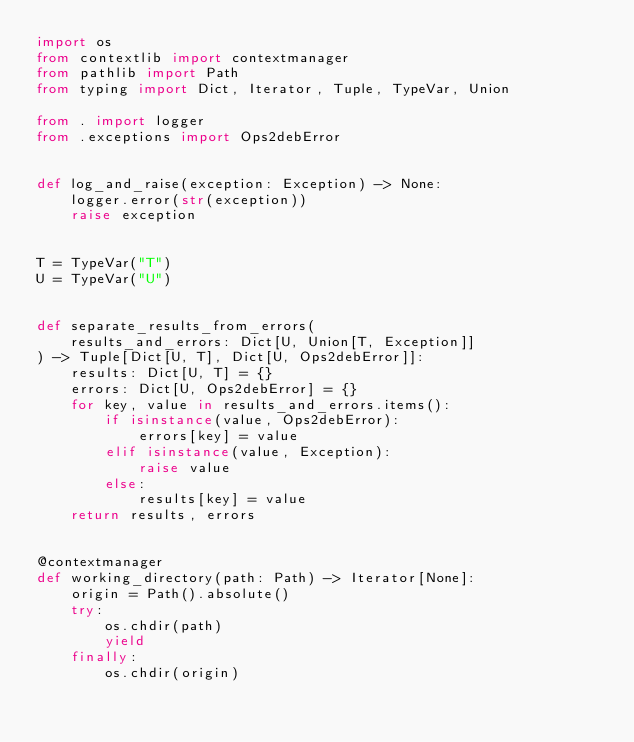<code> <loc_0><loc_0><loc_500><loc_500><_Python_>import os
from contextlib import contextmanager
from pathlib import Path
from typing import Dict, Iterator, Tuple, TypeVar, Union

from . import logger
from .exceptions import Ops2debError


def log_and_raise(exception: Exception) -> None:
    logger.error(str(exception))
    raise exception


T = TypeVar("T")
U = TypeVar("U")


def separate_results_from_errors(
    results_and_errors: Dict[U, Union[T, Exception]]
) -> Tuple[Dict[U, T], Dict[U, Ops2debError]]:
    results: Dict[U, T] = {}
    errors: Dict[U, Ops2debError] = {}
    for key, value in results_and_errors.items():
        if isinstance(value, Ops2debError):
            errors[key] = value
        elif isinstance(value, Exception):
            raise value
        else:
            results[key] = value
    return results, errors


@contextmanager
def working_directory(path: Path) -> Iterator[None]:
    origin = Path().absolute()
    try:
        os.chdir(path)
        yield
    finally:
        os.chdir(origin)
</code> 